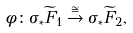<formula> <loc_0><loc_0><loc_500><loc_500>\phi \colon \sigma _ { \ast } \widetilde { F } _ { 1 } \stackrel { \cong } { \to } \sigma _ { \ast } \widetilde { F } _ { 2 } ,</formula> 